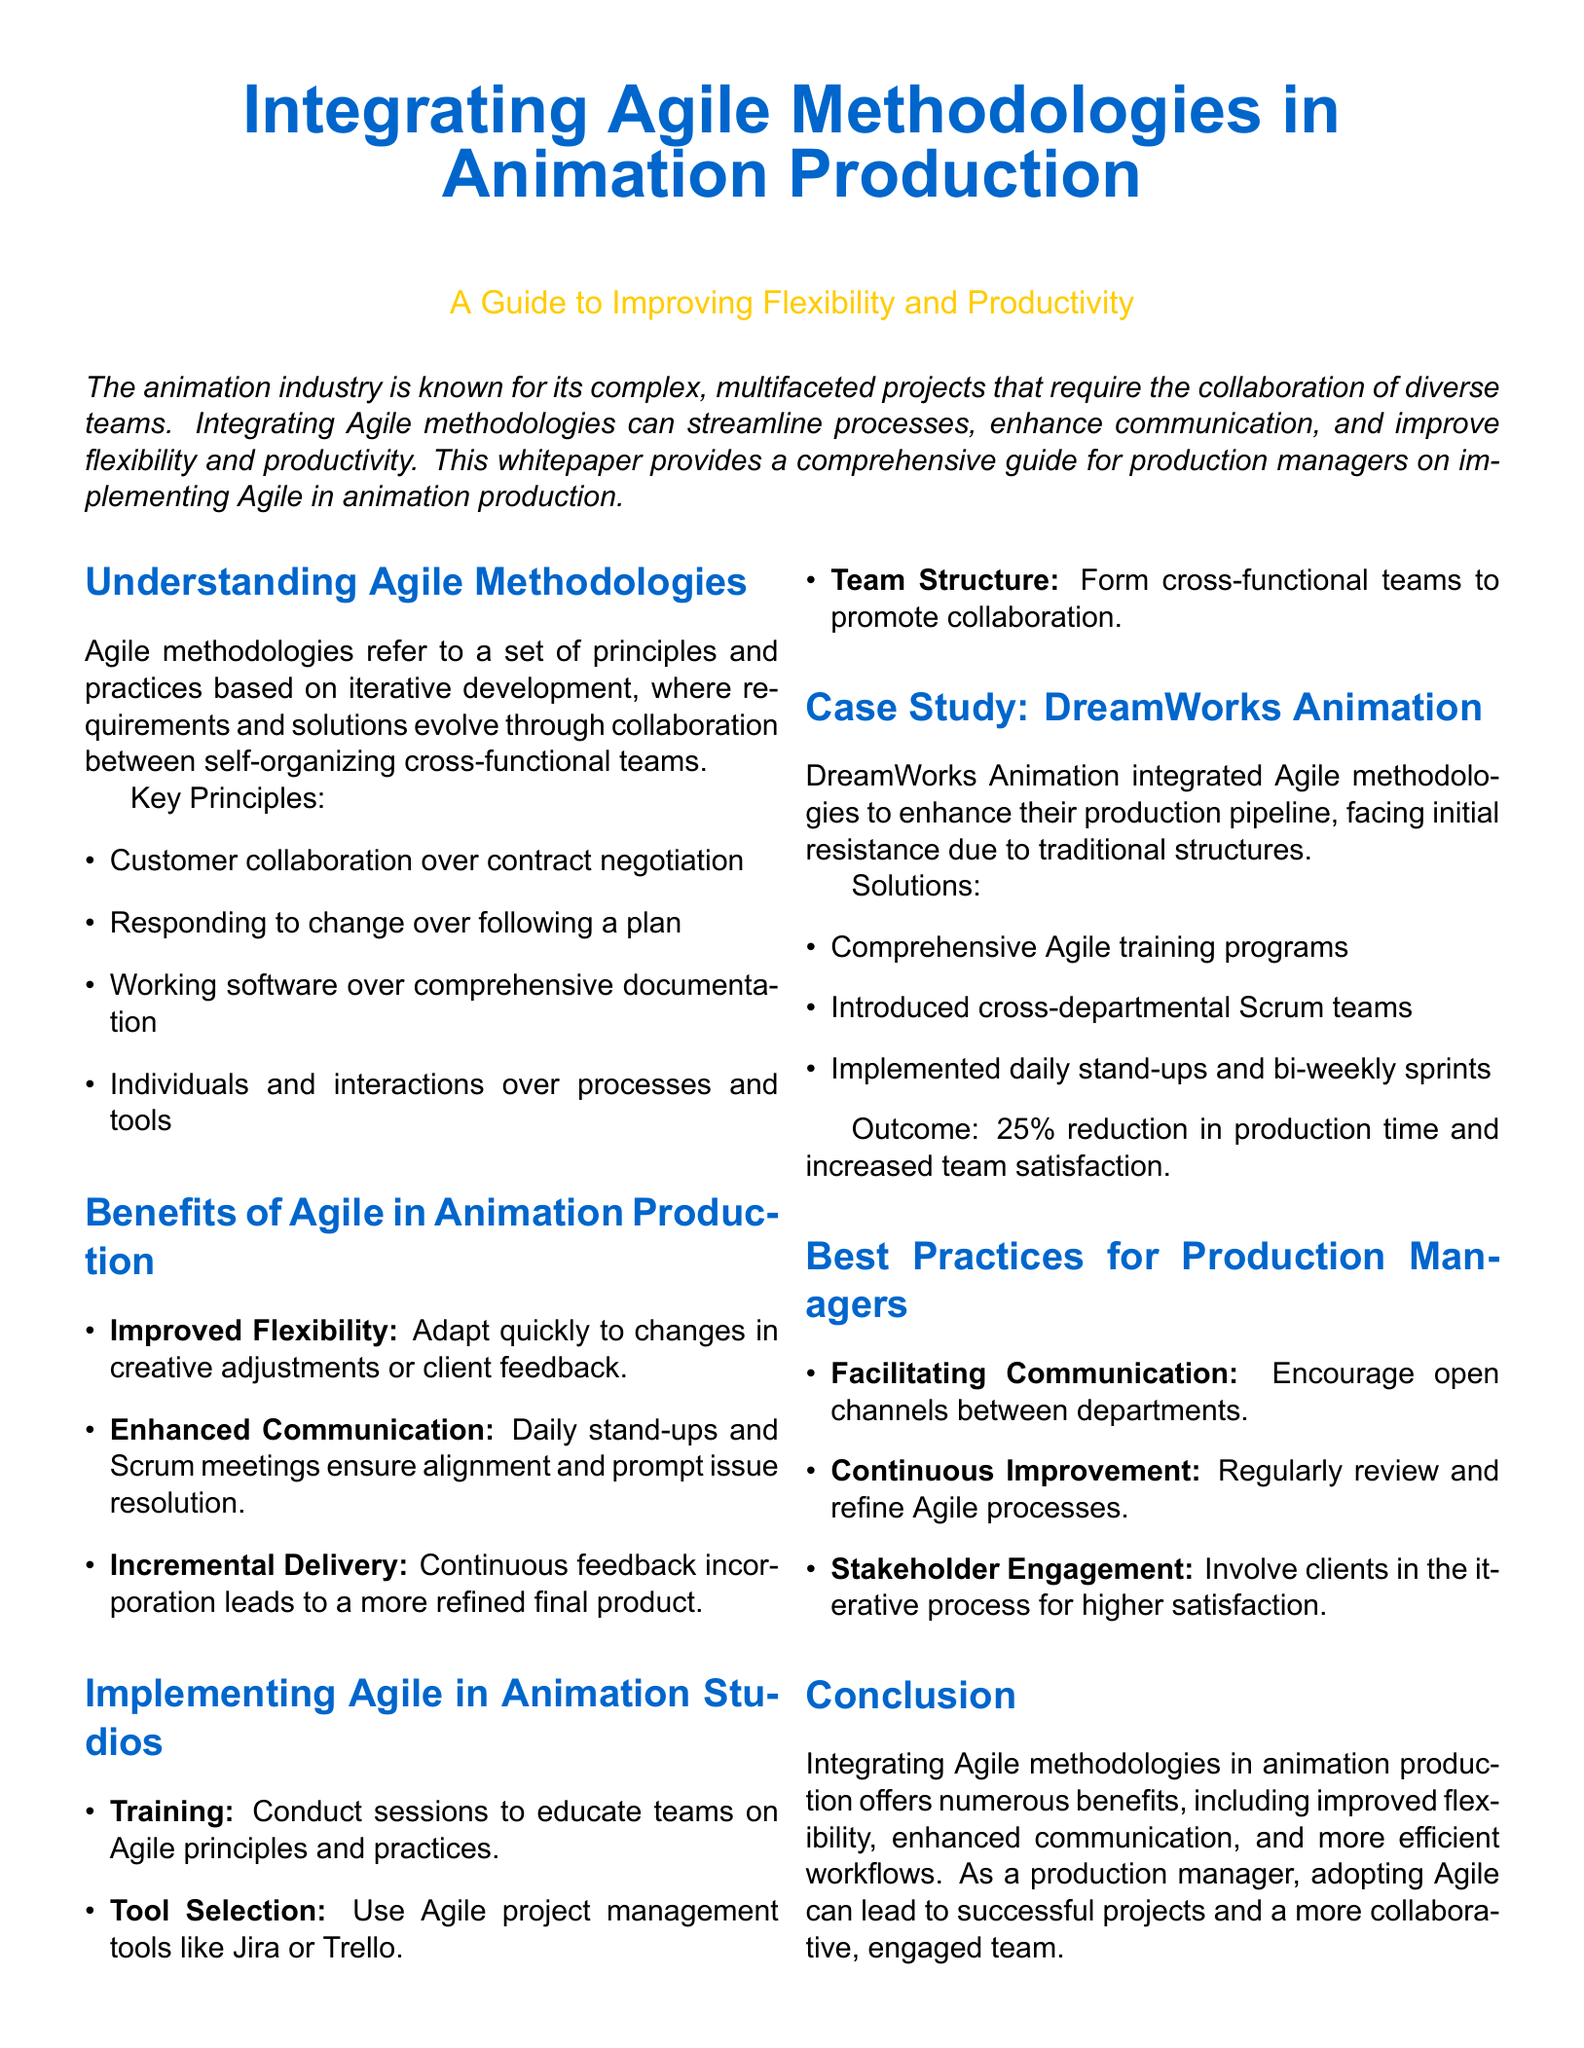What are the key principles of Agile methodologies? The document lists key principles such as customer collaboration, responding to change, working software, and individuals and interactions.
Answer: Customer collaboration, responding to change, working software, individuals and interactions What is one benefit of Agile in animation production? The document highlights several benefits, one being improved flexibility in adapting to changes.
Answer: Improved Flexibility How much was the reduction in production time reported by DreamWorks Animation? The document states that DreamWorks Animation experienced a 25% reduction in production time after implementing Agile.
Answer: 25% What was one solution implemented by DreamWorks Animation to overcome resistance? The document mentions that comprehensive Agile training programs were introduced to address initial resistance.
Answer: Comprehensive Agile training programs What role does stakeholder engagement play in Agile methodologies according to the best practices? The document specifies that involving clients in the iterative process leads to higher satisfaction.
Answer: Higher satisfaction 